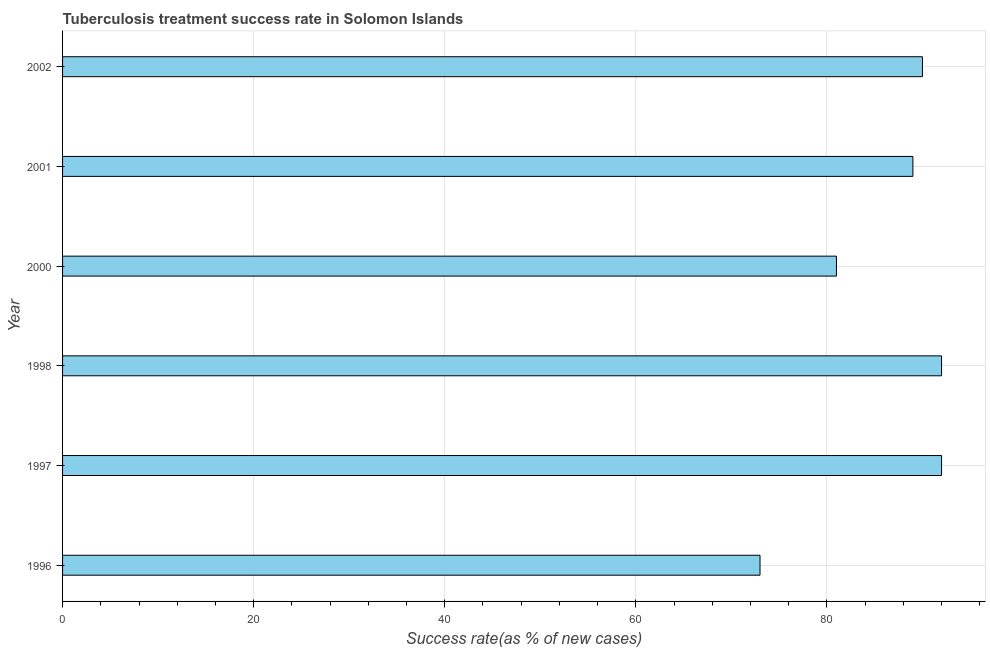Does the graph contain any zero values?
Your response must be concise. No. What is the title of the graph?
Keep it short and to the point. Tuberculosis treatment success rate in Solomon Islands. What is the label or title of the X-axis?
Your answer should be compact. Success rate(as % of new cases). What is the label or title of the Y-axis?
Your answer should be compact. Year. What is the tuberculosis treatment success rate in 2000?
Provide a short and direct response. 81. Across all years, what is the maximum tuberculosis treatment success rate?
Give a very brief answer. 92. What is the sum of the tuberculosis treatment success rate?
Offer a terse response. 517. What is the difference between the tuberculosis treatment success rate in 1997 and 1998?
Give a very brief answer. 0. What is the median tuberculosis treatment success rate?
Offer a very short reply. 89.5. In how many years, is the tuberculosis treatment success rate greater than 92 %?
Provide a short and direct response. 0. What is the ratio of the tuberculosis treatment success rate in 1998 to that in 2001?
Provide a succinct answer. 1.03. Is the tuberculosis treatment success rate in 1996 less than that in 2002?
Your answer should be very brief. Yes. Is the difference between the tuberculosis treatment success rate in 2000 and 2001 greater than the difference between any two years?
Your answer should be very brief. No. Is the sum of the tuberculosis treatment success rate in 1998 and 2002 greater than the maximum tuberculosis treatment success rate across all years?
Offer a very short reply. Yes. What is the difference between the highest and the lowest tuberculosis treatment success rate?
Ensure brevity in your answer.  19. In how many years, is the tuberculosis treatment success rate greater than the average tuberculosis treatment success rate taken over all years?
Provide a short and direct response. 4. How many bars are there?
Your response must be concise. 6. What is the difference between two consecutive major ticks on the X-axis?
Your answer should be very brief. 20. What is the Success rate(as % of new cases) of 1997?
Give a very brief answer. 92. What is the Success rate(as % of new cases) of 1998?
Ensure brevity in your answer.  92. What is the Success rate(as % of new cases) in 2000?
Keep it short and to the point. 81. What is the Success rate(as % of new cases) in 2001?
Your answer should be very brief. 89. What is the Success rate(as % of new cases) of 2002?
Offer a terse response. 90. What is the difference between the Success rate(as % of new cases) in 1996 and 1998?
Provide a succinct answer. -19. What is the difference between the Success rate(as % of new cases) in 1996 and 2002?
Offer a very short reply. -17. What is the difference between the Success rate(as % of new cases) in 1997 and 1998?
Make the answer very short. 0. What is the difference between the Success rate(as % of new cases) in 1997 and 2000?
Make the answer very short. 11. What is the difference between the Success rate(as % of new cases) in 1997 and 2001?
Keep it short and to the point. 3. What is the difference between the Success rate(as % of new cases) in 1997 and 2002?
Make the answer very short. 2. What is the difference between the Success rate(as % of new cases) in 2001 and 2002?
Your answer should be compact. -1. What is the ratio of the Success rate(as % of new cases) in 1996 to that in 1997?
Offer a terse response. 0.79. What is the ratio of the Success rate(as % of new cases) in 1996 to that in 1998?
Provide a succinct answer. 0.79. What is the ratio of the Success rate(as % of new cases) in 1996 to that in 2000?
Offer a terse response. 0.9. What is the ratio of the Success rate(as % of new cases) in 1996 to that in 2001?
Your response must be concise. 0.82. What is the ratio of the Success rate(as % of new cases) in 1996 to that in 2002?
Make the answer very short. 0.81. What is the ratio of the Success rate(as % of new cases) in 1997 to that in 1998?
Offer a terse response. 1. What is the ratio of the Success rate(as % of new cases) in 1997 to that in 2000?
Offer a terse response. 1.14. What is the ratio of the Success rate(as % of new cases) in 1997 to that in 2001?
Give a very brief answer. 1.03. What is the ratio of the Success rate(as % of new cases) in 1998 to that in 2000?
Make the answer very short. 1.14. What is the ratio of the Success rate(as % of new cases) in 1998 to that in 2001?
Give a very brief answer. 1.03. What is the ratio of the Success rate(as % of new cases) in 2000 to that in 2001?
Give a very brief answer. 0.91. What is the ratio of the Success rate(as % of new cases) in 2001 to that in 2002?
Give a very brief answer. 0.99. 